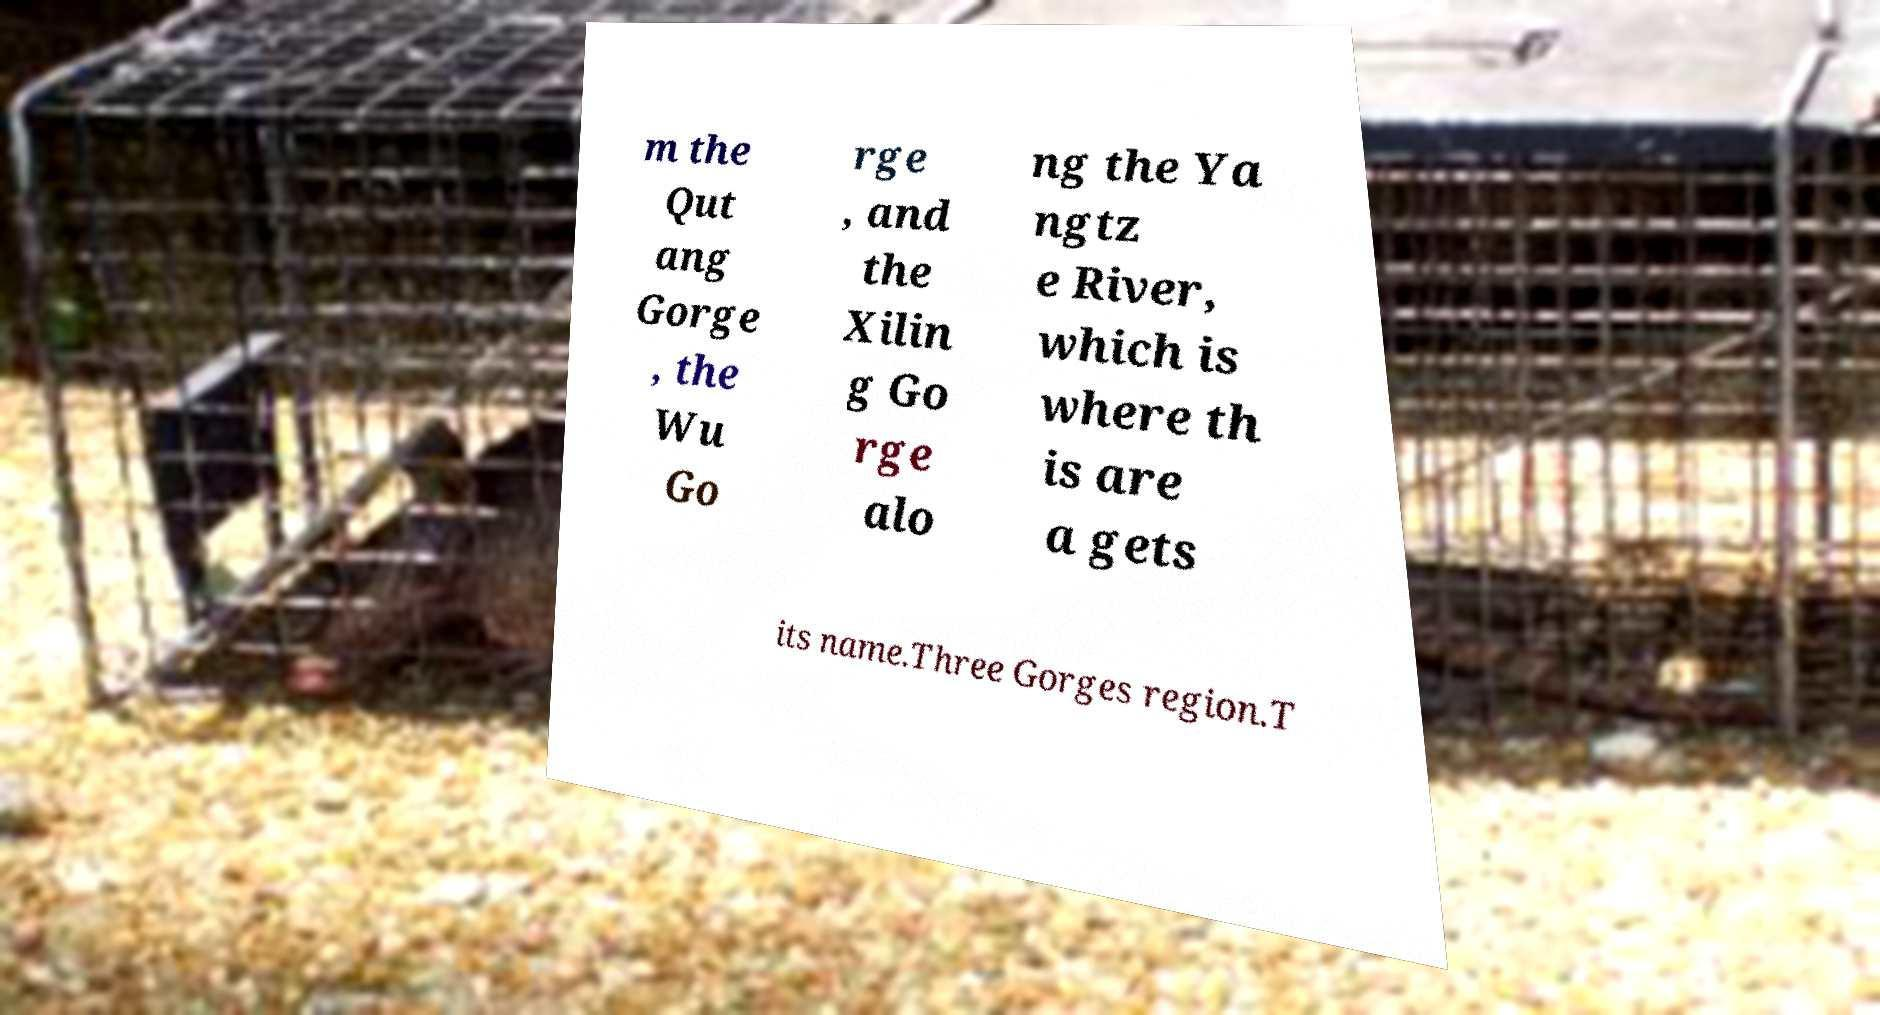For documentation purposes, I need the text within this image transcribed. Could you provide that? m the Qut ang Gorge , the Wu Go rge , and the Xilin g Go rge alo ng the Ya ngtz e River, which is where th is are a gets its name.Three Gorges region.T 